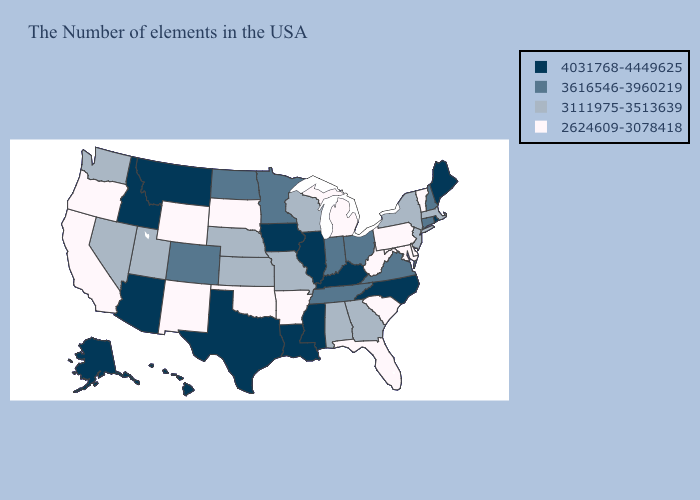What is the value of Michigan?
Keep it brief. 2624609-3078418. Among the states that border Missouri , which have the highest value?
Quick response, please. Kentucky, Illinois, Iowa. Does the first symbol in the legend represent the smallest category?
Write a very short answer. No. Among the states that border Kansas , which have the lowest value?
Be succinct. Oklahoma. Which states have the lowest value in the USA?
Write a very short answer. Vermont, Delaware, Maryland, Pennsylvania, South Carolina, West Virginia, Florida, Michigan, Arkansas, Oklahoma, South Dakota, Wyoming, New Mexico, California, Oregon. Does the map have missing data?
Give a very brief answer. No. What is the value of Wisconsin?
Write a very short answer. 3111975-3513639. What is the lowest value in states that border Oklahoma?
Answer briefly. 2624609-3078418. Among the states that border Mississippi , does Arkansas have the lowest value?
Answer briefly. Yes. What is the highest value in the USA?
Keep it brief. 4031768-4449625. Name the states that have a value in the range 4031768-4449625?
Concise answer only. Maine, Rhode Island, North Carolina, Kentucky, Illinois, Mississippi, Louisiana, Iowa, Texas, Montana, Arizona, Idaho, Alaska, Hawaii. What is the value of Rhode Island?
Quick response, please. 4031768-4449625. Does Delaware have the highest value in the USA?
Be succinct. No. What is the value of Kansas?
Write a very short answer. 3111975-3513639. Is the legend a continuous bar?
Concise answer only. No. 